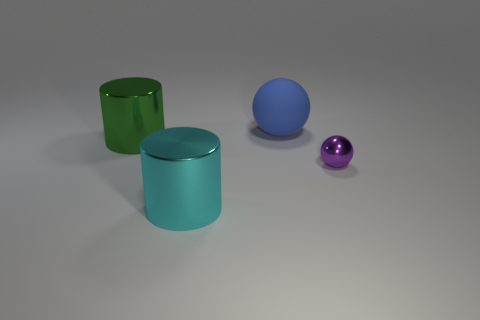Add 3 large rubber balls. How many objects exist? 7 Subtract all big green metal balls. Subtract all big green metal things. How many objects are left? 3 Add 1 big green things. How many big green things are left? 2 Add 2 rubber spheres. How many rubber spheres exist? 3 Subtract 0 brown cylinders. How many objects are left? 4 